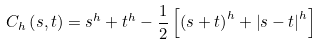<formula> <loc_0><loc_0><loc_500><loc_500>C _ { h } \left ( s , t \right ) = s ^ { h } + t ^ { h } - \frac { 1 } { 2 } \left [ \left ( s + t \right ) ^ { h } + \left | s - t \right | ^ { h } \right ]</formula> 